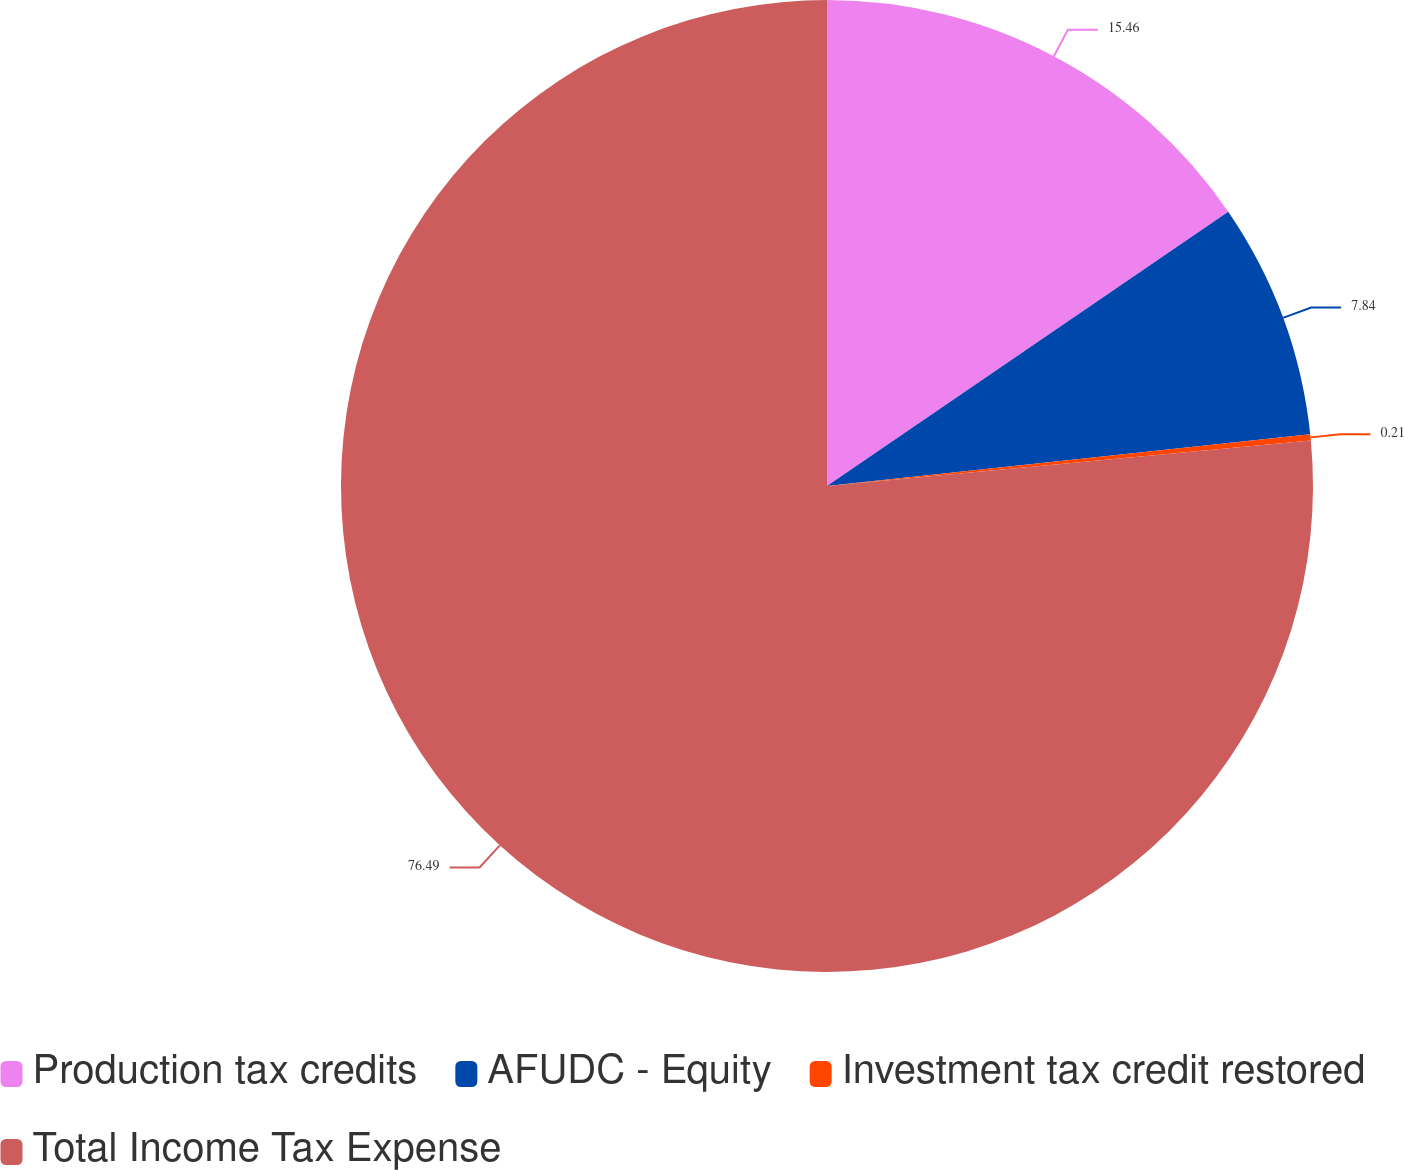Convert chart. <chart><loc_0><loc_0><loc_500><loc_500><pie_chart><fcel>Production tax credits<fcel>AFUDC - Equity<fcel>Investment tax credit restored<fcel>Total Income Tax Expense<nl><fcel>15.46%<fcel>7.84%<fcel>0.21%<fcel>76.49%<nl></chart> 